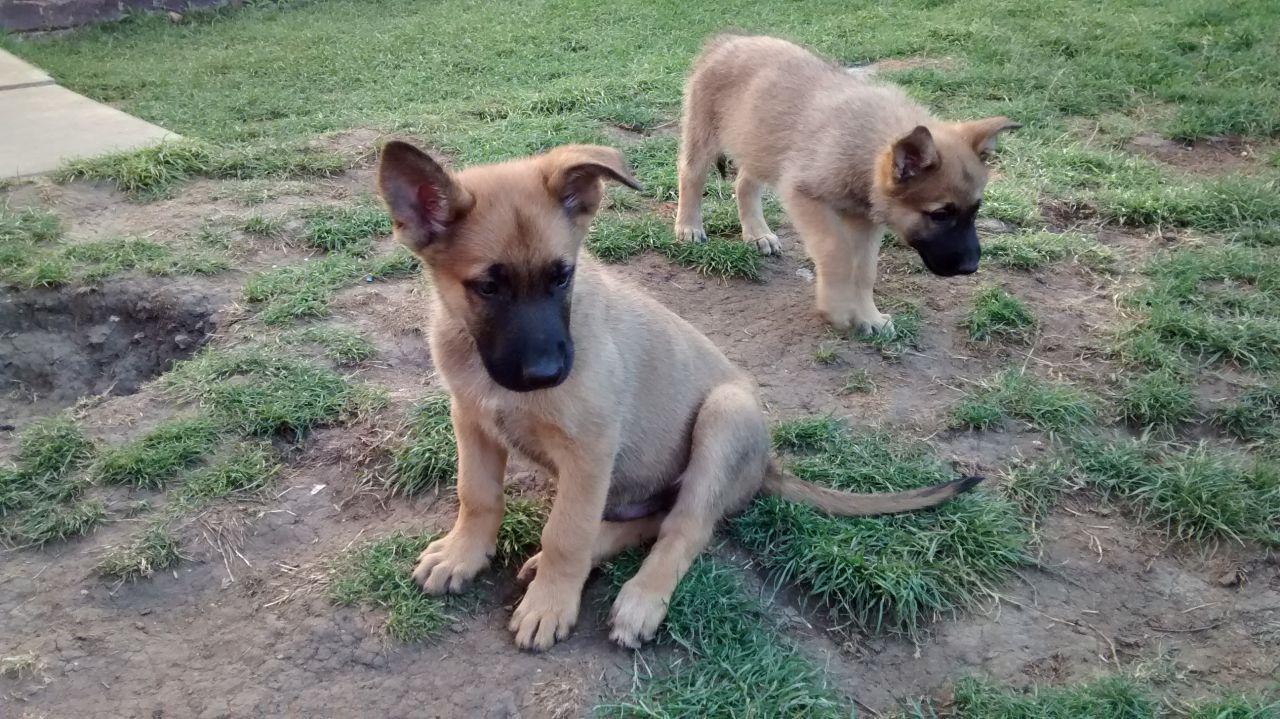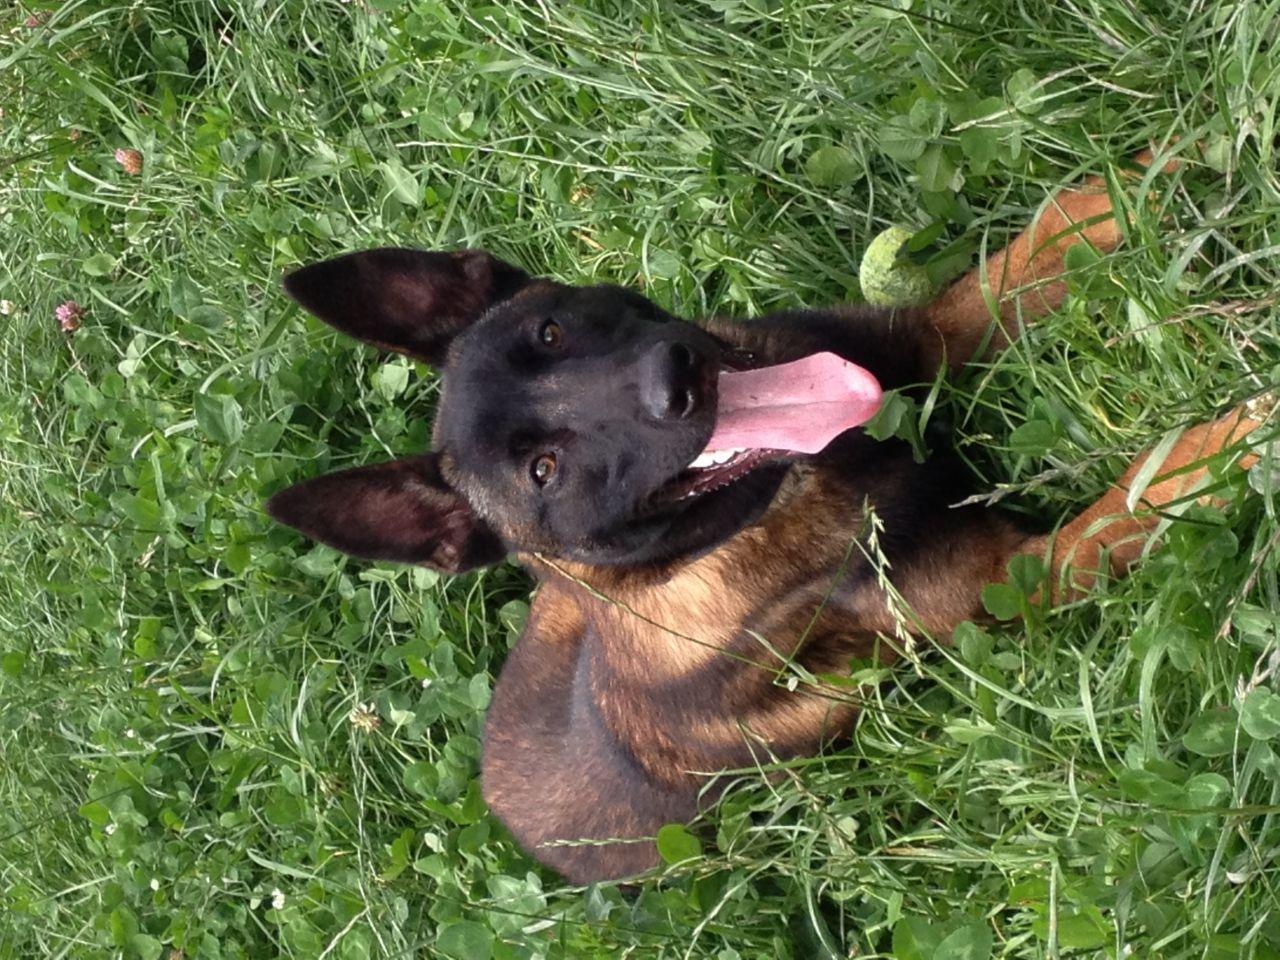The first image is the image on the left, the second image is the image on the right. Considering the images on both sides, is "An image shows exactly one german shepherd dog, which is reclining on the grass." valid? Answer yes or no. Yes. The first image is the image on the left, the second image is the image on the right. Analyze the images presented: Is the assertion "In one of the images there is a large dog laying in the grass." valid? Answer yes or no. Yes. 